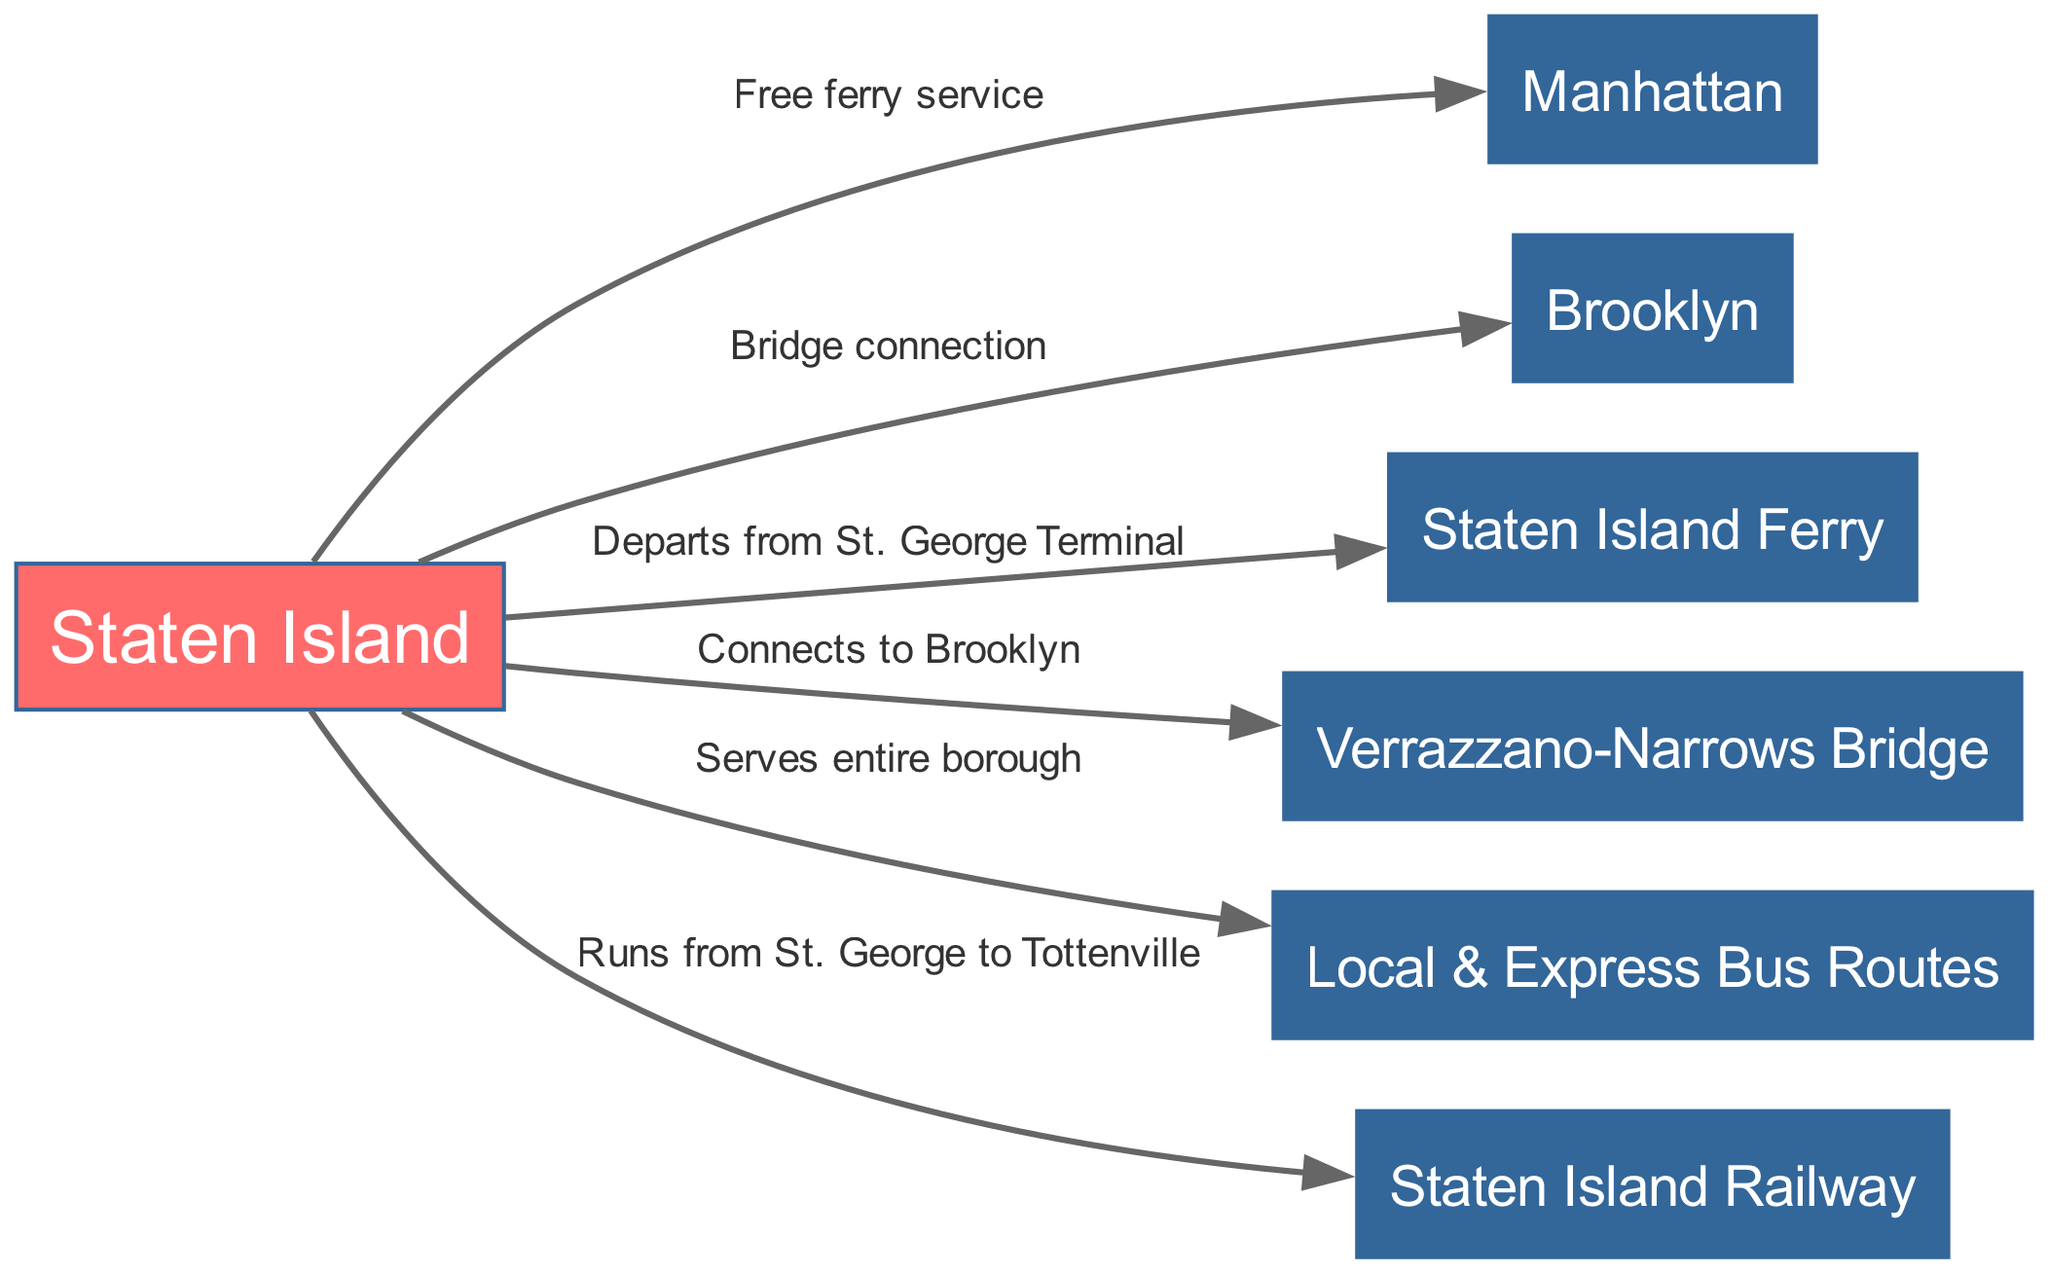What are the main connections from Staten Island? The diagram shows that Staten Island connects to Manhattan via a free ferry service, to Brooklyn via a bridge connection, and has local and express bus routes that serve the entire borough. Additionally, it connects to the Staten Island Railway, which runs from St. George to Tottenville.
Answer: Manhattan, Brooklyn, bus routes, Staten Island Railway What connects Staten Island to Brooklyn? The diagram indicates that the connection from Staten Island to Brooklyn is labeled as a bridge connection. This suggests an infrastructure link that facilitates travel between the two areas.
Answer: Bridge connection How many nodes are there in the diagram? By counting the distinct points labeled in the diagram, we see that there are a total of six nodes: Staten Island, Manhattan, Brooklyn, Staten Island Ferry, Verrazzano-Narrows Bridge, and Staten Island Railway.
Answer: Six What is the service frequency of the Staten Island Ferry? The diagram shows that the Staten Island Ferry operates a free ferry service from Staten Island to Manhattan, indicating that it is a regular transportation option available to travelers without charge.
Answer: Free ferry service What is the route of the Staten Island Railway? The diagram explicitly states that the Staten Island Railway runs from St. George to Tottenville. This provides geographic insight into the railway's coverage within Staten Island and its endpoints.
Answer: St. George to Tottenville What infrastructure connects Staten Island to Manhattan? According to the diagram, the only infrastructure connecting Staten Island to Manhattan is the Staten Island Ferry, which provides free transport between these two locations.
Answer: Staten Island Ferry What type of services serve the entire borough of Staten Island? The diagram describes local and express bus routes as serving the entire borough of Staten Island, showing the public transportation options available to residents.
Answer: Local & Express Bus Routes How does Staten Island connect to Brooklyn aside from the ferry? In the diagram, the connection to Brooklyn other than the ferry is through the Verrazzano-Narrows Bridge, indicating a road-based link for vehicular traffic between Staten Island and Brooklyn.
Answer: Verrazzano-Narrows Bridge 